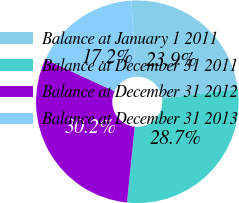Convert chart to OTSL. <chart><loc_0><loc_0><loc_500><loc_500><pie_chart><fcel>Balance at January 1 2011<fcel>Balance at December 31 2011<fcel>Balance at December 31 2012<fcel>Balance at December 31 2013<nl><fcel>23.9%<fcel>28.66%<fcel>30.25%<fcel>17.19%<nl></chart> 